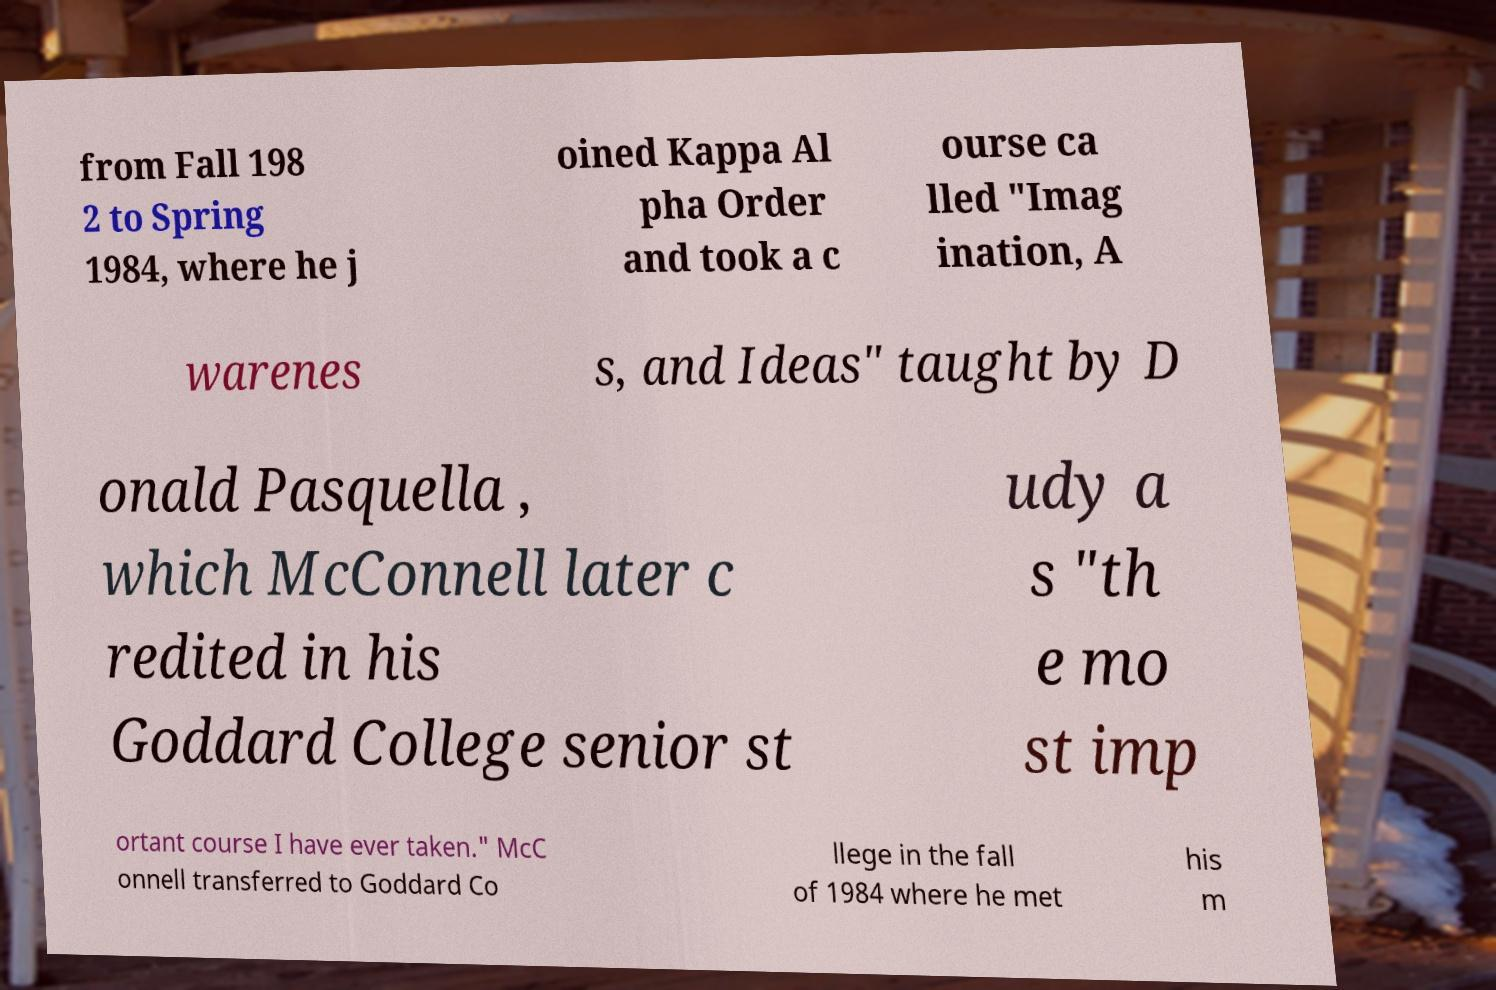Can you accurately transcribe the text from the provided image for me? from Fall 198 2 to Spring 1984, where he j oined Kappa Al pha Order and took a c ourse ca lled "Imag ination, A warenes s, and Ideas" taught by D onald Pasquella , which McConnell later c redited in his Goddard College senior st udy a s "th e mo st imp ortant course I have ever taken." McC onnell transferred to Goddard Co llege in the fall of 1984 where he met his m 